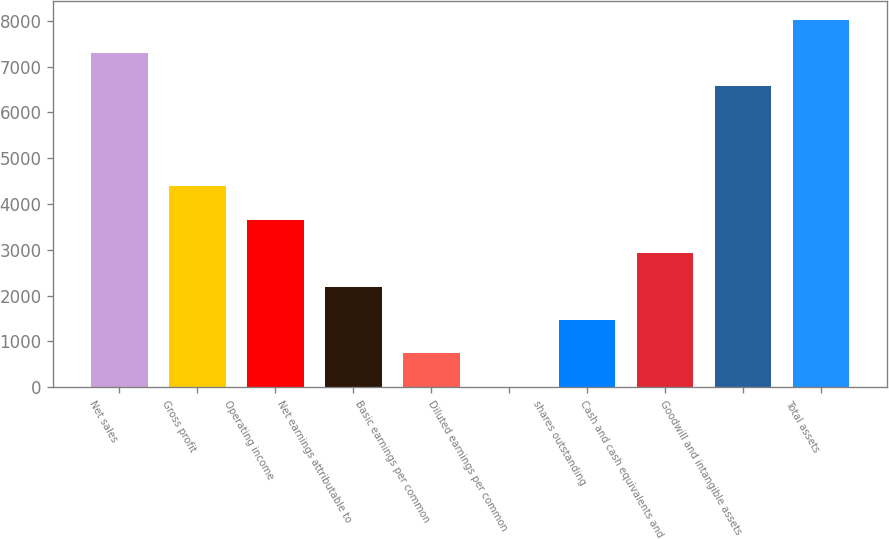<chart> <loc_0><loc_0><loc_500><loc_500><bar_chart><fcel>Net sales<fcel>Gross profit<fcel>Operating income<fcel>Net earnings attributable to<fcel>Basic earnings per common<fcel>Diluted earnings per common<fcel>shares outstanding<fcel>Cash and cash equivalents and<fcel>Goodwill and intangible assets<fcel>Total assets<nl><fcel>7301.81<fcel>4383.45<fcel>3653.86<fcel>2194.68<fcel>735.5<fcel>5.91<fcel>1465.09<fcel>2924.27<fcel>6572.22<fcel>8031.4<nl></chart> 